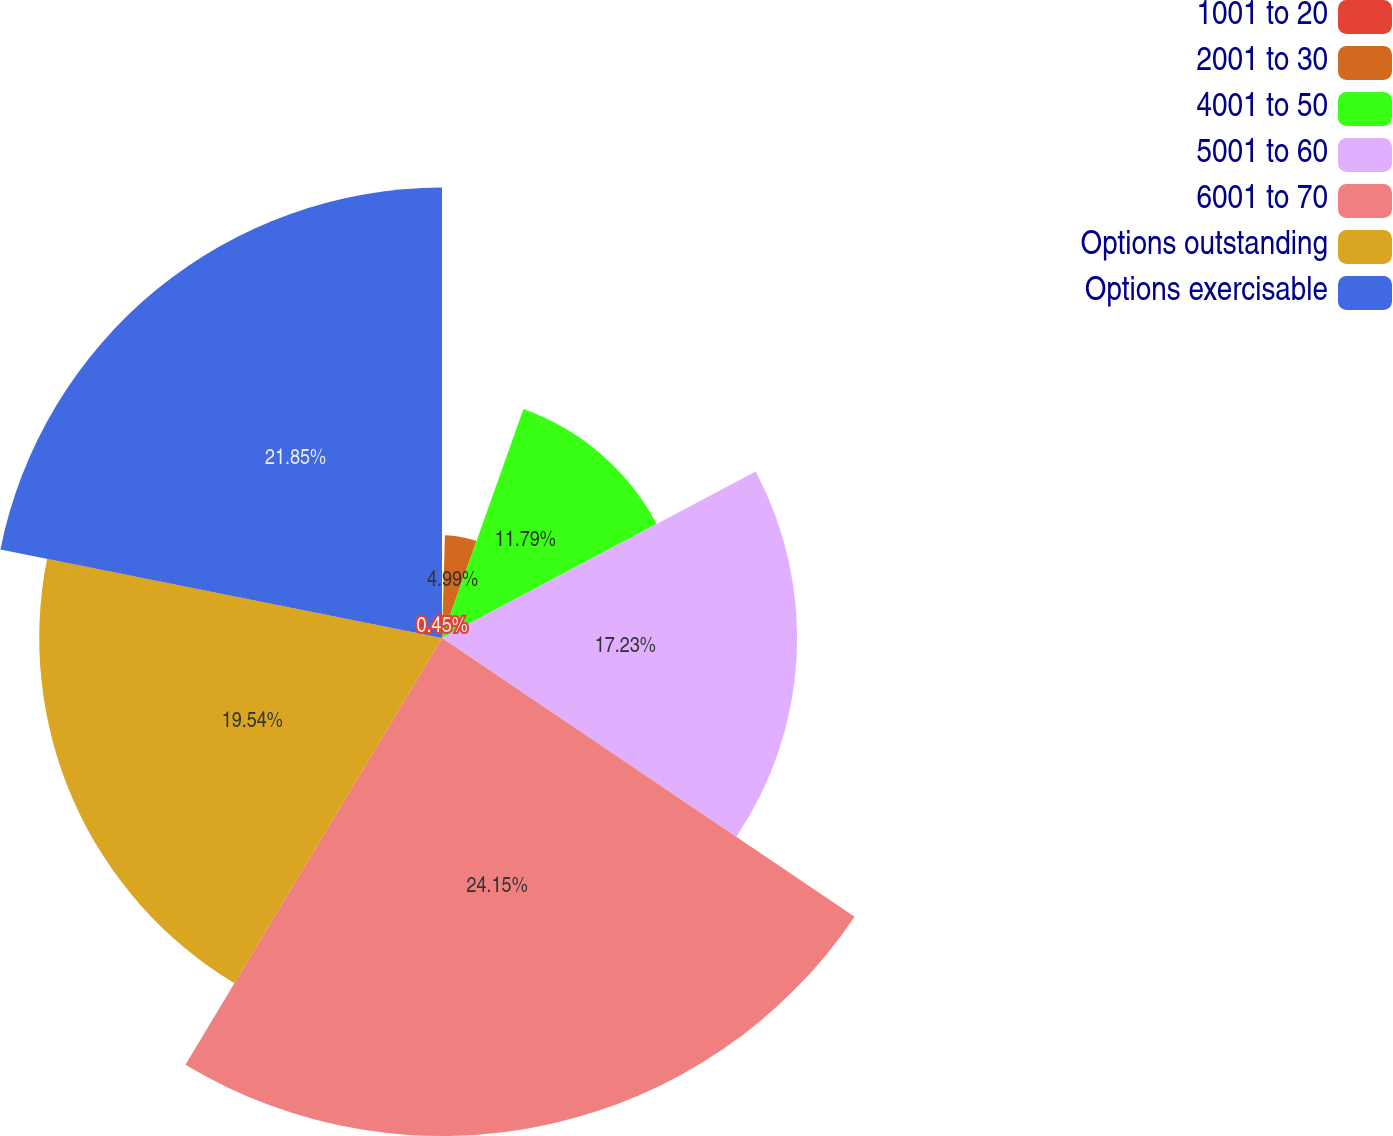Convert chart to OTSL. <chart><loc_0><loc_0><loc_500><loc_500><pie_chart><fcel>1001 to 20<fcel>2001 to 30<fcel>4001 to 50<fcel>5001 to 60<fcel>6001 to 70<fcel>Options outstanding<fcel>Options exercisable<nl><fcel>0.45%<fcel>4.99%<fcel>11.79%<fcel>17.23%<fcel>24.16%<fcel>19.54%<fcel>21.85%<nl></chart> 